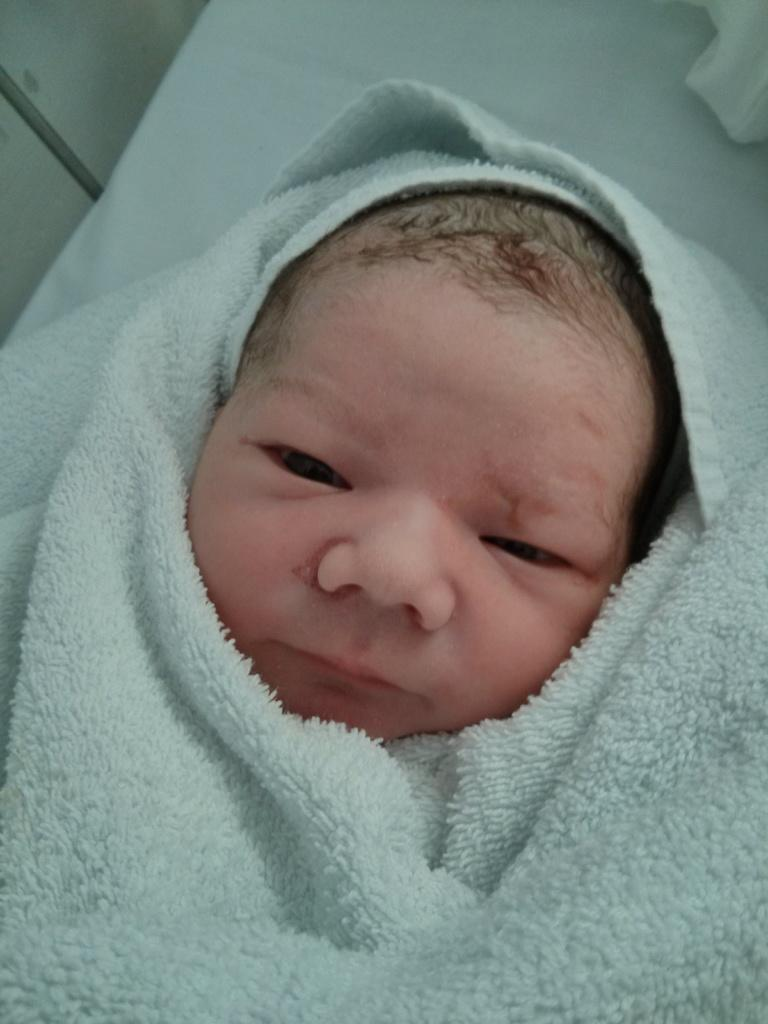What is the main subject of the image? The main subject of the image is a baby. How is the baby dressed or covered in the image? The baby is wrapped in a towel. What type of argument is the carpenter having with the lawyer in the image? There is no carpenter or lawyer present in the image; it only features a baby wrapped in a towel. 